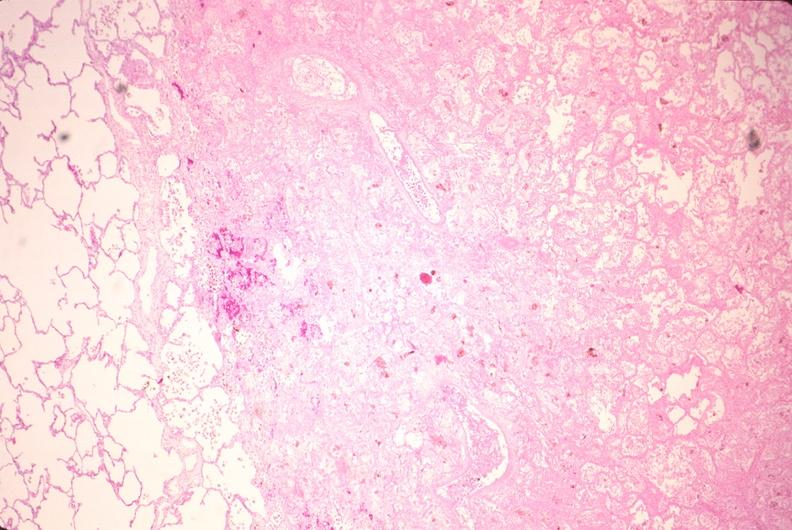s metastatic pancreas carcinoma present?
Answer the question using a single word or phrase. No 